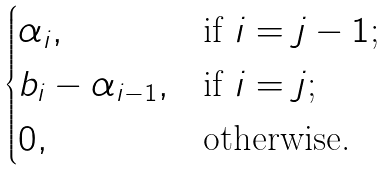<formula> <loc_0><loc_0><loc_500><loc_500>\begin{cases} \alpha _ { i } , & \text {if $i=j-1$;} \\ b _ { i } - \alpha _ { i - 1 } , & \text {if $i=j$;} \\ 0 , & \text {otherwise.} \end{cases}</formula> 